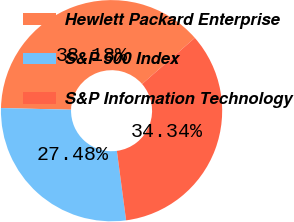Convert chart to OTSL. <chart><loc_0><loc_0><loc_500><loc_500><pie_chart><fcel>Hewlett Packard Enterprise<fcel>S&P 500 Index<fcel>S&P Information Technology<nl><fcel>38.18%<fcel>27.48%<fcel>34.34%<nl></chart> 